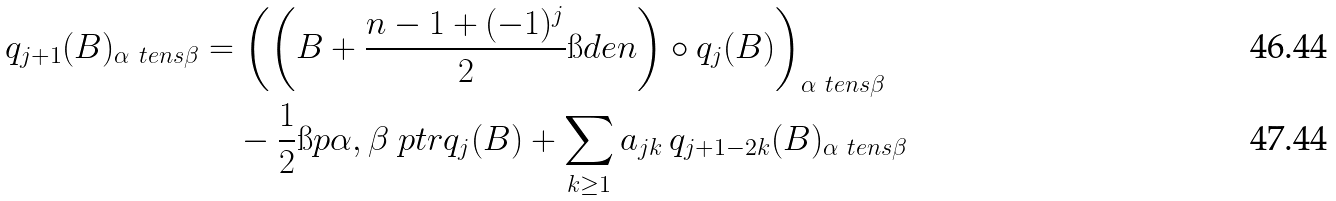Convert formula to latex. <formula><loc_0><loc_0><loc_500><loc_500>q _ { j + 1 } ( B ) _ { \alpha \ t e n s \beta } & = \left ( \left ( B + \frac { n - 1 + ( - 1 ) ^ { j } } 2 \i d e n \right ) \circ q _ { j } ( B ) \right ) _ { \alpha \ t e n s \beta } \\ & \quad - \frac { 1 } { 2 } \i p { \alpha , \beta } \ p t r q _ { j } ( B ) + \sum _ { k \geq 1 } a _ { j k } \, q _ { j + 1 - 2 k } ( B ) _ { \alpha \ t e n s \beta }</formula> 